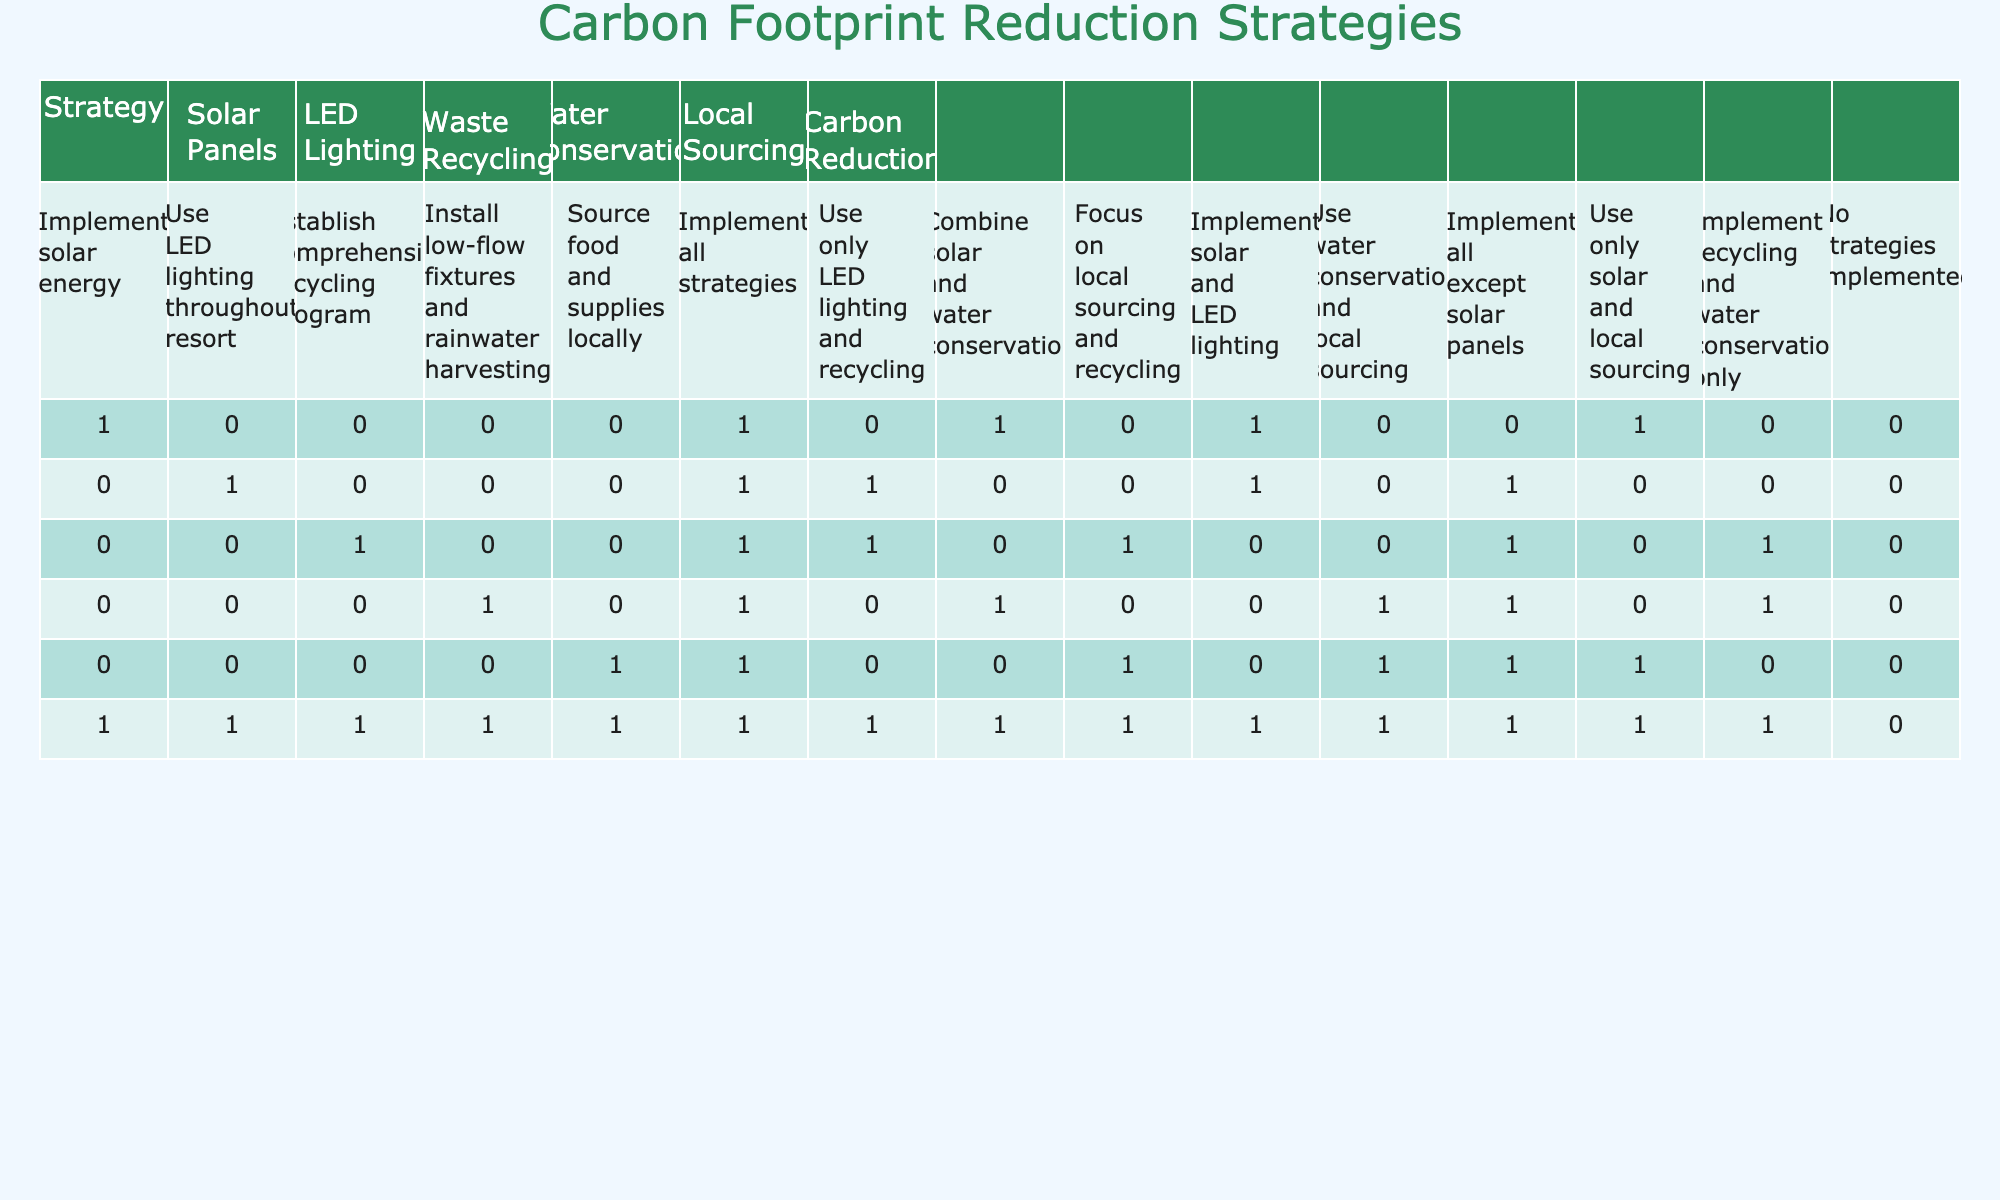What strategies contribute to carbon reduction? The table lists several strategies and shows that all strategies contribute to carbon reduction, denoted by a "1" in the "Carbon Reduction" column. These strategies include implementing solar energy, using LED lighting, establishing a recycling program, installing low-flow fixtures, using local sourcing, and combining all strategies.
Answer: All listed strategies contribute Which strategy is focused on local sourcing? The strategy "Source food and supplies locally" is directly mentioned in the table with local sourcing indicated, showing a "1" in the "Carbon Reduction" column.
Answer: Source food and supplies locally Are there any strategies that do not reduce carbon footprint? The last row, labeled "No strategies implemented," indicates that there are no carbon reduction efforts, as reflected by the "0" in the "Carbon Reduction" column.
Answer: Yes, there are strategies that do not reduce carbon footprint How many strategies use LED lighting? By inspecting the table, the following strategies utilize LED lighting: "Use LED lighting throughout resort," "Use only LED lighting and recycling," and "Implement solar and LED lighting." Counting these gives a total of three strategies.
Answer: Three strategies use LED lighting What is the total number of strategies that implement water conservation? There are four strategies in the table that include water conservation: "Install low-flow fixtures and rainwater harvesting," "Use water conservation and local sourcing," "Implement recycling and water conservation only," and "Implement all strategies." Summing these gives a total of four strategies implementing water conservation.
Answer: Four strategies implement water conservation Do any strategies focus exclusively on recycling? The strategy "Implement recycling and water conservation only" exclusively mentions recycling and outlines it. Other strategies also include recycling as part of a broader effort. Therefore, no strategy focuses solely on recycling without other components.
Answer: No strategies focus exclusively on recycling What is the combination of strategies that includes solar and water conservation? The strategy "Combine solar and water conservation" includes both solar energy and water conservation. This entry contains a "1" for carbon reduction, indicating that this combination effectively contributes to carbon reduction.
Answer: Combine solar and water conservation Can you identify a strategy that combines local sourcing and recycling? The strategy "Focus on local sourcing and recycling" directly combines local sourcing and recycling. The entry shows a "1" in the "Carbon Reduction" column, indicating its effectiveness in reducing carbon footprint.
Answer: Focus on local sourcing and recycling How many strategies implement local sourcing but do not utilize solar panels? The strategies "Source food and supplies locally" and "Focus on local sourcing and recycling" both implement local sourcing without including solar panels. This totals to two strategies.
Answer: Two strategies implement local sourcing without solar panels 